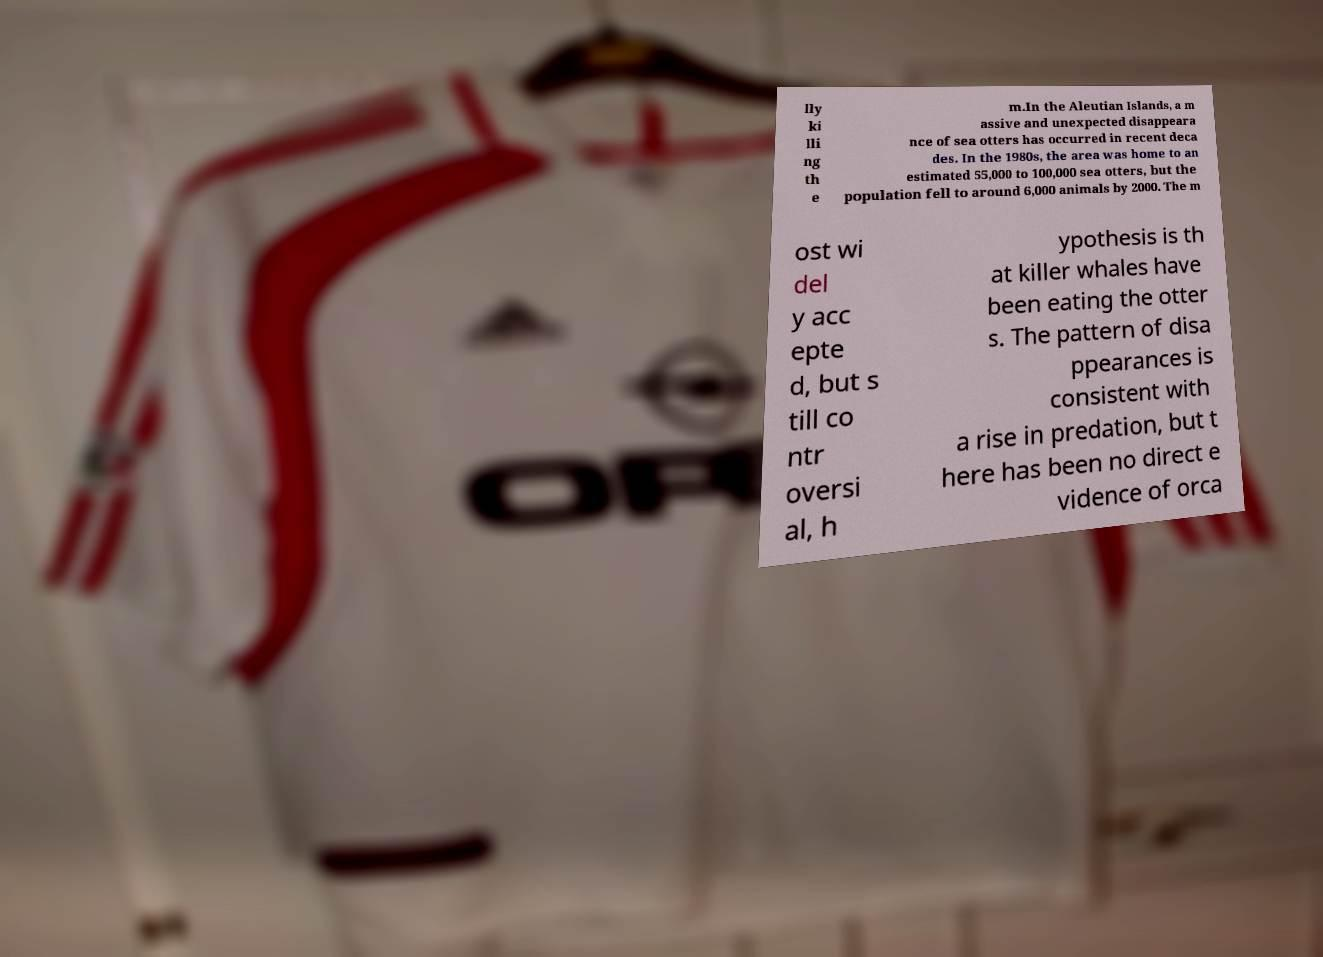There's text embedded in this image that I need extracted. Can you transcribe it verbatim? lly ki lli ng th e m.In the Aleutian Islands, a m assive and unexpected disappeara nce of sea otters has occurred in recent deca des. In the 1980s, the area was home to an estimated 55,000 to 100,000 sea otters, but the population fell to around 6,000 animals by 2000. The m ost wi del y acc epte d, but s till co ntr oversi al, h ypothesis is th at killer whales have been eating the otter s. The pattern of disa ppearances is consistent with a rise in predation, but t here has been no direct e vidence of orca 